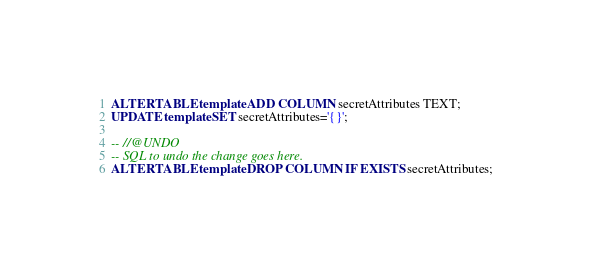<code> <loc_0><loc_0><loc_500><loc_500><_SQL_>ALTER TABLE template ADD COLUMN secretAttributes TEXT;
UPDATE template SET secretAttributes='{}';

-- //@UNDO
-- SQL to undo the change goes here.
ALTER TABLE template DROP COLUMN IF EXISTS secretAttributes;


</code> 